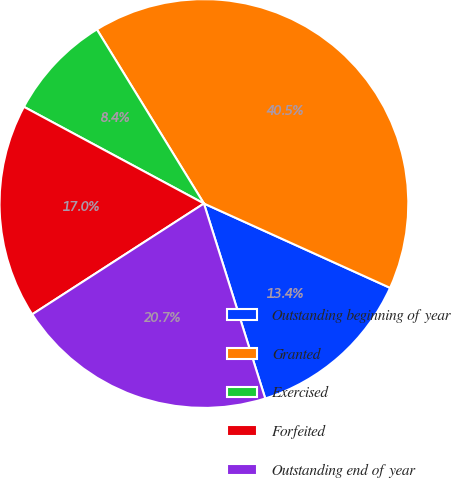<chart> <loc_0><loc_0><loc_500><loc_500><pie_chart><fcel>Outstanding beginning of year<fcel>Granted<fcel>Exercised<fcel>Forfeited<fcel>Outstanding end of year<nl><fcel>13.38%<fcel>40.55%<fcel>8.38%<fcel>16.97%<fcel>20.73%<nl></chart> 